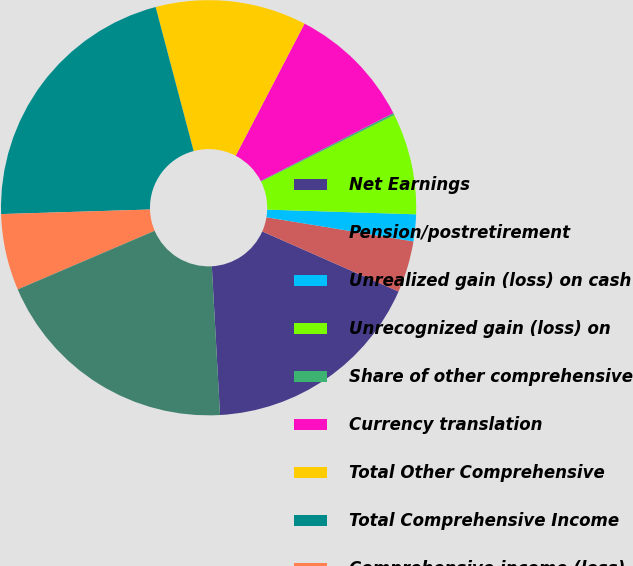Convert chart. <chart><loc_0><loc_0><loc_500><loc_500><pie_chart><fcel>Net Earnings<fcel>Pension/postretirement<fcel>Unrealized gain (loss) on cash<fcel>Unrecognized gain (loss) on<fcel>Share of other comprehensive<fcel>Currency translation<fcel>Total Other Comprehensive<fcel>Total Comprehensive Income<fcel>Comprehensive income (loss)<fcel>Comprehensive Income<nl><fcel>17.51%<fcel>4.02%<fcel>2.09%<fcel>7.88%<fcel>0.16%<fcel>9.82%<fcel>11.75%<fcel>21.38%<fcel>5.95%<fcel>19.44%<nl></chart> 